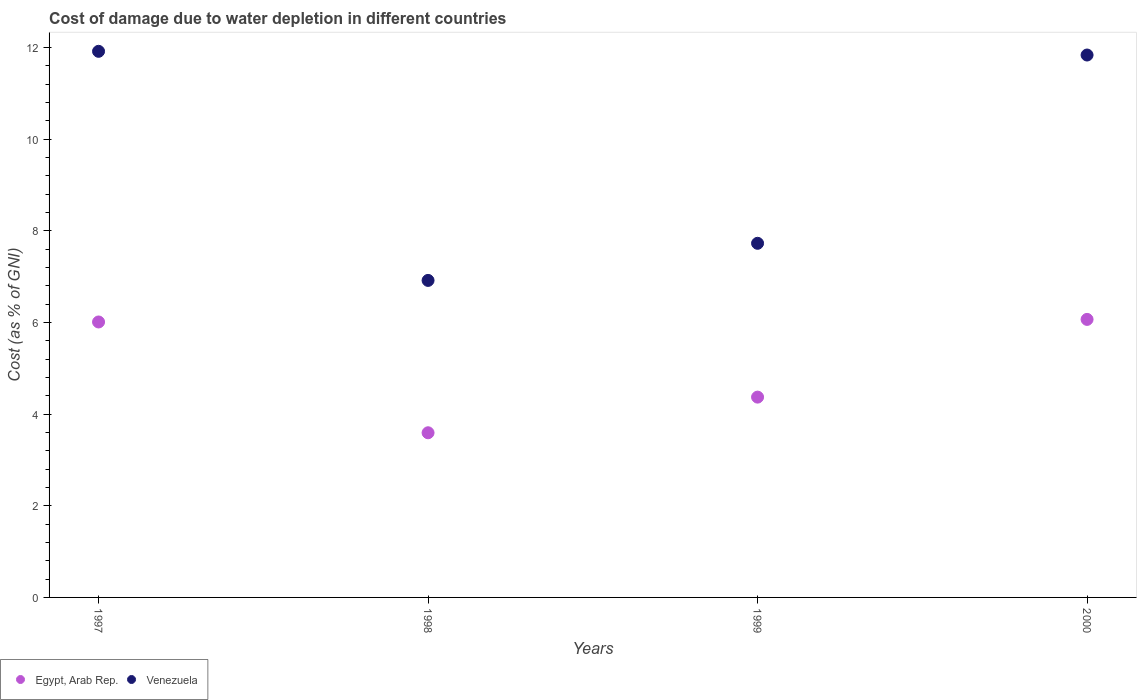How many different coloured dotlines are there?
Offer a terse response. 2. Is the number of dotlines equal to the number of legend labels?
Make the answer very short. Yes. What is the cost of damage caused due to water depletion in Egypt, Arab Rep. in 1998?
Your response must be concise. 3.59. Across all years, what is the maximum cost of damage caused due to water depletion in Egypt, Arab Rep.?
Offer a very short reply. 6.07. Across all years, what is the minimum cost of damage caused due to water depletion in Venezuela?
Ensure brevity in your answer.  6.92. In which year was the cost of damage caused due to water depletion in Egypt, Arab Rep. minimum?
Your answer should be very brief. 1998. What is the total cost of damage caused due to water depletion in Venezuela in the graph?
Provide a short and direct response. 38.4. What is the difference between the cost of damage caused due to water depletion in Egypt, Arab Rep. in 1999 and that in 2000?
Make the answer very short. -1.7. What is the difference between the cost of damage caused due to water depletion in Egypt, Arab Rep. in 1998 and the cost of damage caused due to water depletion in Venezuela in 1999?
Provide a short and direct response. -4.13. What is the average cost of damage caused due to water depletion in Venezuela per year?
Provide a succinct answer. 9.6. In the year 1997, what is the difference between the cost of damage caused due to water depletion in Egypt, Arab Rep. and cost of damage caused due to water depletion in Venezuela?
Provide a succinct answer. -5.91. What is the ratio of the cost of damage caused due to water depletion in Egypt, Arab Rep. in 1998 to that in 1999?
Provide a succinct answer. 0.82. What is the difference between the highest and the second highest cost of damage caused due to water depletion in Egypt, Arab Rep.?
Provide a short and direct response. 0.06. What is the difference between the highest and the lowest cost of damage caused due to water depletion in Venezuela?
Offer a very short reply. 5. In how many years, is the cost of damage caused due to water depletion in Egypt, Arab Rep. greater than the average cost of damage caused due to water depletion in Egypt, Arab Rep. taken over all years?
Offer a very short reply. 2. Does the cost of damage caused due to water depletion in Egypt, Arab Rep. monotonically increase over the years?
Offer a very short reply. No. Is the cost of damage caused due to water depletion in Venezuela strictly less than the cost of damage caused due to water depletion in Egypt, Arab Rep. over the years?
Your response must be concise. No. How many dotlines are there?
Ensure brevity in your answer.  2. How many years are there in the graph?
Ensure brevity in your answer.  4. What is the difference between two consecutive major ticks on the Y-axis?
Your answer should be very brief. 2. Are the values on the major ticks of Y-axis written in scientific E-notation?
Make the answer very short. No. How many legend labels are there?
Provide a short and direct response. 2. What is the title of the graph?
Keep it short and to the point. Cost of damage due to water depletion in different countries. Does "Djibouti" appear as one of the legend labels in the graph?
Keep it short and to the point. No. What is the label or title of the X-axis?
Your response must be concise. Years. What is the label or title of the Y-axis?
Ensure brevity in your answer.  Cost (as % of GNI). What is the Cost (as % of GNI) in Egypt, Arab Rep. in 1997?
Keep it short and to the point. 6.01. What is the Cost (as % of GNI) of Venezuela in 1997?
Offer a very short reply. 11.92. What is the Cost (as % of GNI) of Egypt, Arab Rep. in 1998?
Provide a succinct answer. 3.59. What is the Cost (as % of GNI) of Venezuela in 1998?
Offer a terse response. 6.92. What is the Cost (as % of GNI) of Egypt, Arab Rep. in 1999?
Offer a terse response. 4.37. What is the Cost (as % of GNI) of Venezuela in 1999?
Your response must be concise. 7.73. What is the Cost (as % of GNI) of Egypt, Arab Rep. in 2000?
Provide a short and direct response. 6.07. What is the Cost (as % of GNI) in Venezuela in 2000?
Ensure brevity in your answer.  11.84. Across all years, what is the maximum Cost (as % of GNI) in Egypt, Arab Rep.?
Your response must be concise. 6.07. Across all years, what is the maximum Cost (as % of GNI) in Venezuela?
Make the answer very short. 11.92. Across all years, what is the minimum Cost (as % of GNI) in Egypt, Arab Rep.?
Provide a short and direct response. 3.59. Across all years, what is the minimum Cost (as % of GNI) in Venezuela?
Provide a succinct answer. 6.92. What is the total Cost (as % of GNI) of Egypt, Arab Rep. in the graph?
Provide a succinct answer. 20.04. What is the total Cost (as % of GNI) in Venezuela in the graph?
Your answer should be compact. 38.4. What is the difference between the Cost (as % of GNI) in Egypt, Arab Rep. in 1997 and that in 1998?
Ensure brevity in your answer.  2.42. What is the difference between the Cost (as % of GNI) of Venezuela in 1997 and that in 1998?
Make the answer very short. 5. What is the difference between the Cost (as % of GNI) of Egypt, Arab Rep. in 1997 and that in 1999?
Ensure brevity in your answer.  1.64. What is the difference between the Cost (as % of GNI) in Venezuela in 1997 and that in 1999?
Offer a terse response. 4.19. What is the difference between the Cost (as % of GNI) in Egypt, Arab Rep. in 1997 and that in 2000?
Provide a short and direct response. -0.06. What is the difference between the Cost (as % of GNI) of Venezuela in 1997 and that in 2000?
Make the answer very short. 0.08. What is the difference between the Cost (as % of GNI) of Egypt, Arab Rep. in 1998 and that in 1999?
Your answer should be very brief. -0.78. What is the difference between the Cost (as % of GNI) in Venezuela in 1998 and that in 1999?
Give a very brief answer. -0.81. What is the difference between the Cost (as % of GNI) in Egypt, Arab Rep. in 1998 and that in 2000?
Offer a very short reply. -2.47. What is the difference between the Cost (as % of GNI) in Venezuela in 1998 and that in 2000?
Keep it short and to the point. -4.92. What is the difference between the Cost (as % of GNI) in Egypt, Arab Rep. in 1999 and that in 2000?
Keep it short and to the point. -1.7. What is the difference between the Cost (as % of GNI) of Venezuela in 1999 and that in 2000?
Your answer should be very brief. -4.11. What is the difference between the Cost (as % of GNI) in Egypt, Arab Rep. in 1997 and the Cost (as % of GNI) in Venezuela in 1998?
Give a very brief answer. -0.91. What is the difference between the Cost (as % of GNI) of Egypt, Arab Rep. in 1997 and the Cost (as % of GNI) of Venezuela in 1999?
Offer a terse response. -1.72. What is the difference between the Cost (as % of GNI) of Egypt, Arab Rep. in 1997 and the Cost (as % of GNI) of Venezuela in 2000?
Your response must be concise. -5.83. What is the difference between the Cost (as % of GNI) of Egypt, Arab Rep. in 1998 and the Cost (as % of GNI) of Venezuela in 1999?
Make the answer very short. -4.13. What is the difference between the Cost (as % of GNI) of Egypt, Arab Rep. in 1998 and the Cost (as % of GNI) of Venezuela in 2000?
Give a very brief answer. -8.24. What is the difference between the Cost (as % of GNI) of Egypt, Arab Rep. in 1999 and the Cost (as % of GNI) of Venezuela in 2000?
Give a very brief answer. -7.47. What is the average Cost (as % of GNI) in Egypt, Arab Rep. per year?
Offer a very short reply. 5.01. What is the average Cost (as % of GNI) in Venezuela per year?
Provide a succinct answer. 9.6. In the year 1997, what is the difference between the Cost (as % of GNI) of Egypt, Arab Rep. and Cost (as % of GNI) of Venezuela?
Provide a succinct answer. -5.91. In the year 1998, what is the difference between the Cost (as % of GNI) in Egypt, Arab Rep. and Cost (as % of GNI) in Venezuela?
Your answer should be compact. -3.32. In the year 1999, what is the difference between the Cost (as % of GNI) of Egypt, Arab Rep. and Cost (as % of GNI) of Venezuela?
Give a very brief answer. -3.36. In the year 2000, what is the difference between the Cost (as % of GNI) of Egypt, Arab Rep. and Cost (as % of GNI) of Venezuela?
Your answer should be compact. -5.77. What is the ratio of the Cost (as % of GNI) of Egypt, Arab Rep. in 1997 to that in 1998?
Offer a very short reply. 1.67. What is the ratio of the Cost (as % of GNI) in Venezuela in 1997 to that in 1998?
Provide a succinct answer. 1.72. What is the ratio of the Cost (as % of GNI) of Egypt, Arab Rep. in 1997 to that in 1999?
Your response must be concise. 1.38. What is the ratio of the Cost (as % of GNI) of Venezuela in 1997 to that in 1999?
Your answer should be very brief. 1.54. What is the ratio of the Cost (as % of GNI) of Venezuela in 1997 to that in 2000?
Provide a succinct answer. 1.01. What is the ratio of the Cost (as % of GNI) in Egypt, Arab Rep. in 1998 to that in 1999?
Give a very brief answer. 0.82. What is the ratio of the Cost (as % of GNI) of Venezuela in 1998 to that in 1999?
Make the answer very short. 0.9. What is the ratio of the Cost (as % of GNI) in Egypt, Arab Rep. in 1998 to that in 2000?
Give a very brief answer. 0.59. What is the ratio of the Cost (as % of GNI) in Venezuela in 1998 to that in 2000?
Keep it short and to the point. 0.58. What is the ratio of the Cost (as % of GNI) in Egypt, Arab Rep. in 1999 to that in 2000?
Offer a very short reply. 0.72. What is the ratio of the Cost (as % of GNI) of Venezuela in 1999 to that in 2000?
Provide a succinct answer. 0.65. What is the difference between the highest and the second highest Cost (as % of GNI) in Egypt, Arab Rep.?
Provide a succinct answer. 0.06. What is the difference between the highest and the second highest Cost (as % of GNI) in Venezuela?
Offer a terse response. 0.08. What is the difference between the highest and the lowest Cost (as % of GNI) in Egypt, Arab Rep.?
Ensure brevity in your answer.  2.47. What is the difference between the highest and the lowest Cost (as % of GNI) in Venezuela?
Offer a very short reply. 5. 